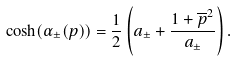<formula> <loc_0><loc_0><loc_500><loc_500>\cosh ( \alpha _ { \pm } ( p ) ) = \frac { 1 } { 2 } \left ( a _ { \pm } + \frac { 1 + \overline { p } ^ { 2 } } { a _ { \pm } } \right ) .</formula> 